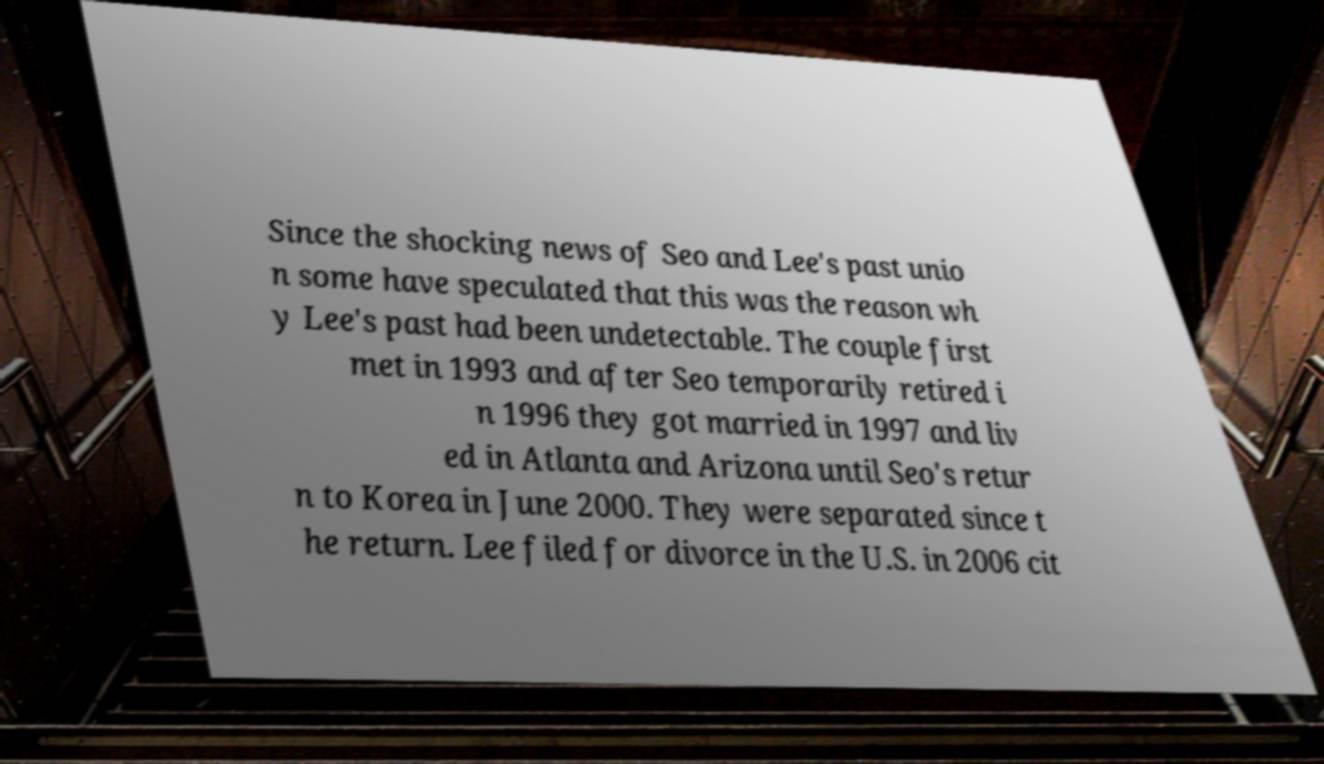I need the written content from this picture converted into text. Can you do that? Since the shocking news of Seo and Lee's past unio n some have speculated that this was the reason wh y Lee's past had been undetectable. The couple first met in 1993 and after Seo temporarily retired i n 1996 they got married in 1997 and liv ed in Atlanta and Arizona until Seo's retur n to Korea in June 2000. They were separated since t he return. Lee filed for divorce in the U.S. in 2006 cit 